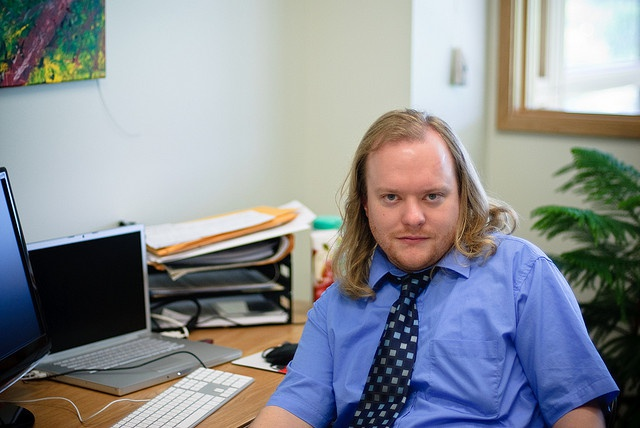Describe the objects in this image and their specific colors. I can see people in black, gray, and blue tones, laptop in black and gray tones, potted plant in black, darkgreen, and gray tones, tv in black, navy, darkgray, and blue tones, and tie in black, navy, gray, and blue tones in this image. 